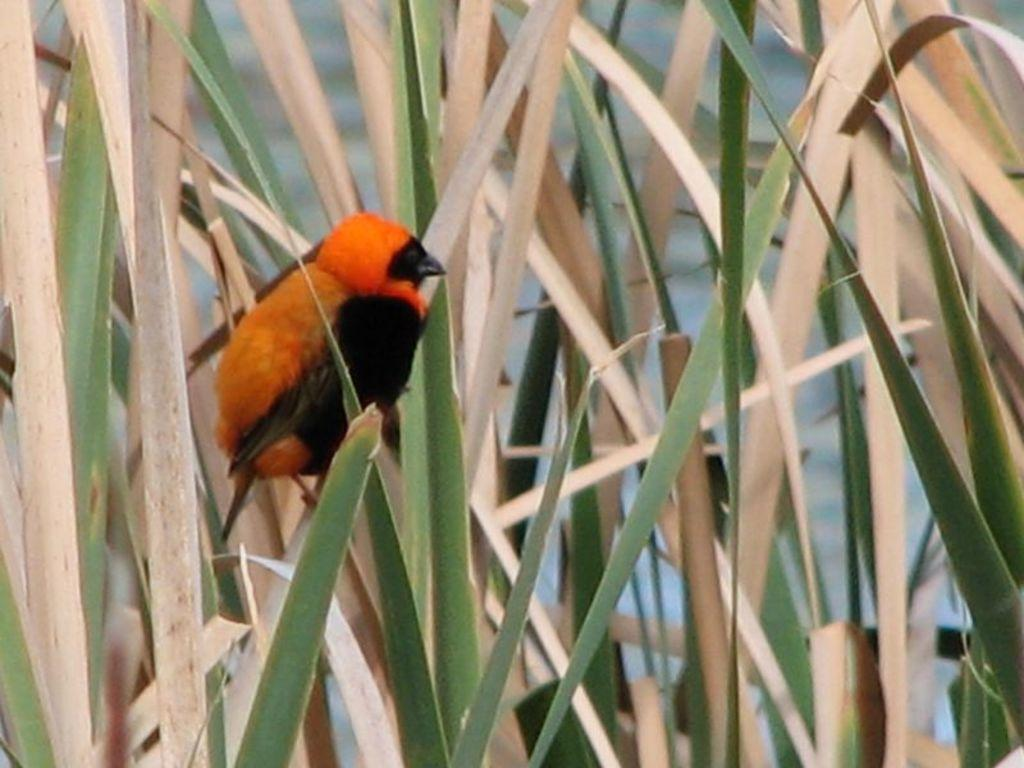What type of animal can be seen in the image? There is a bird in the image. What type of vegetation is present in the image? Green leaves are present in the image. What other type of leaves can be seen in the image? Dry leaves are present in the image. What is the bird's account number in the image? There is no account number associated with the bird in the image, as it is a photograph and not a financial transaction. 